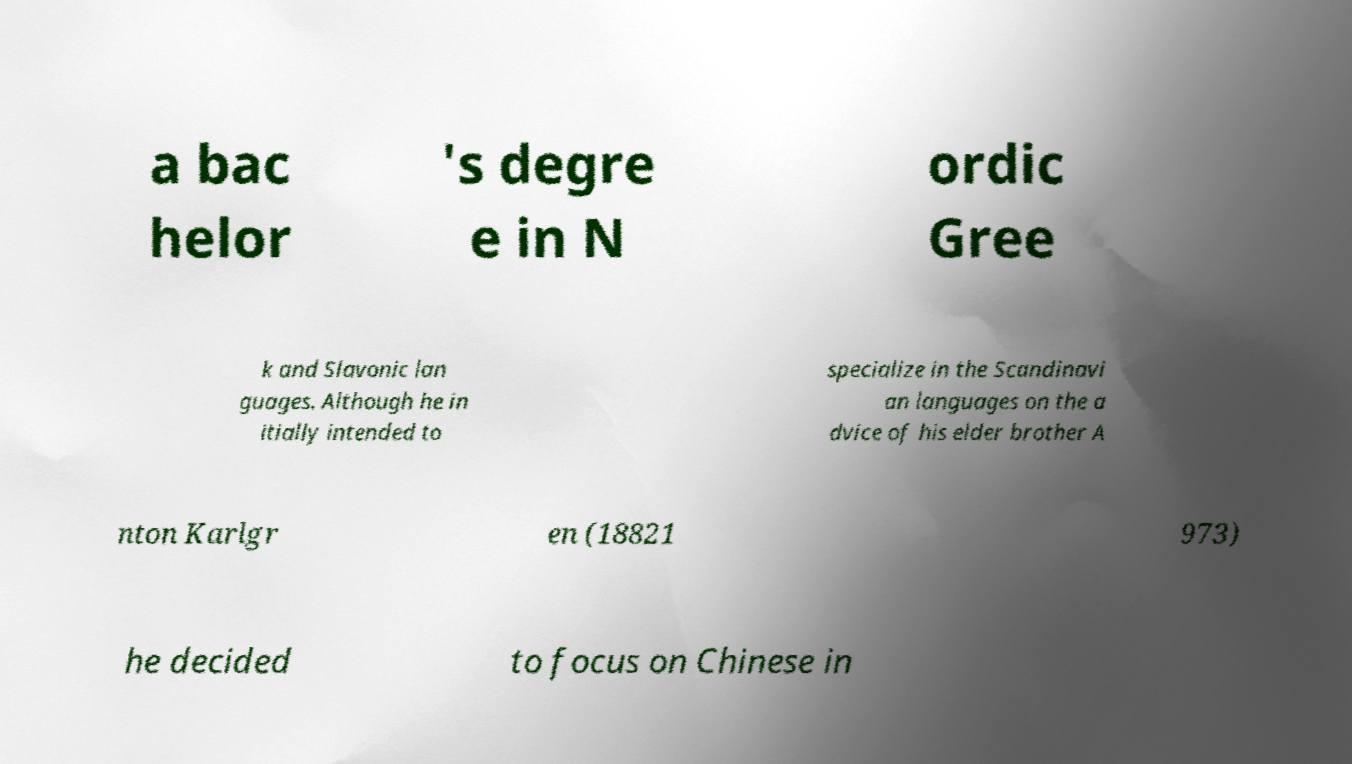Can you read and provide the text displayed in the image?This photo seems to have some interesting text. Can you extract and type it out for me? a bac helor 's degre e in N ordic Gree k and Slavonic lan guages. Although he in itially intended to specialize in the Scandinavi an languages on the a dvice of his elder brother A nton Karlgr en (18821 973) he decided to focus on Chinese in 